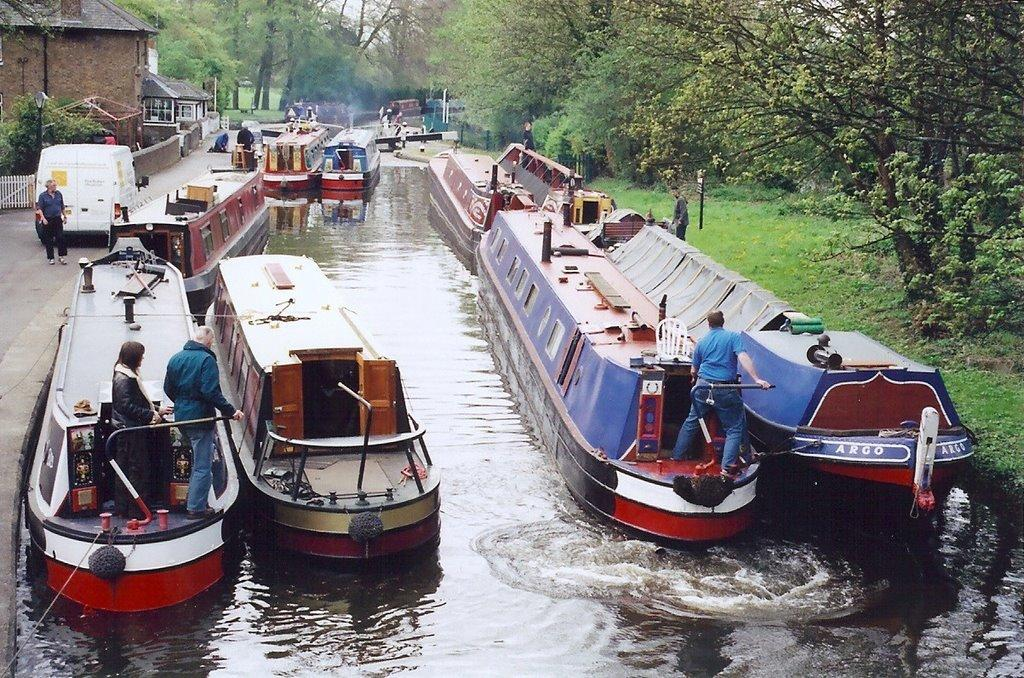<image>
Offer a succinct explanation of the picture presented. the word Argo that is on a boat 